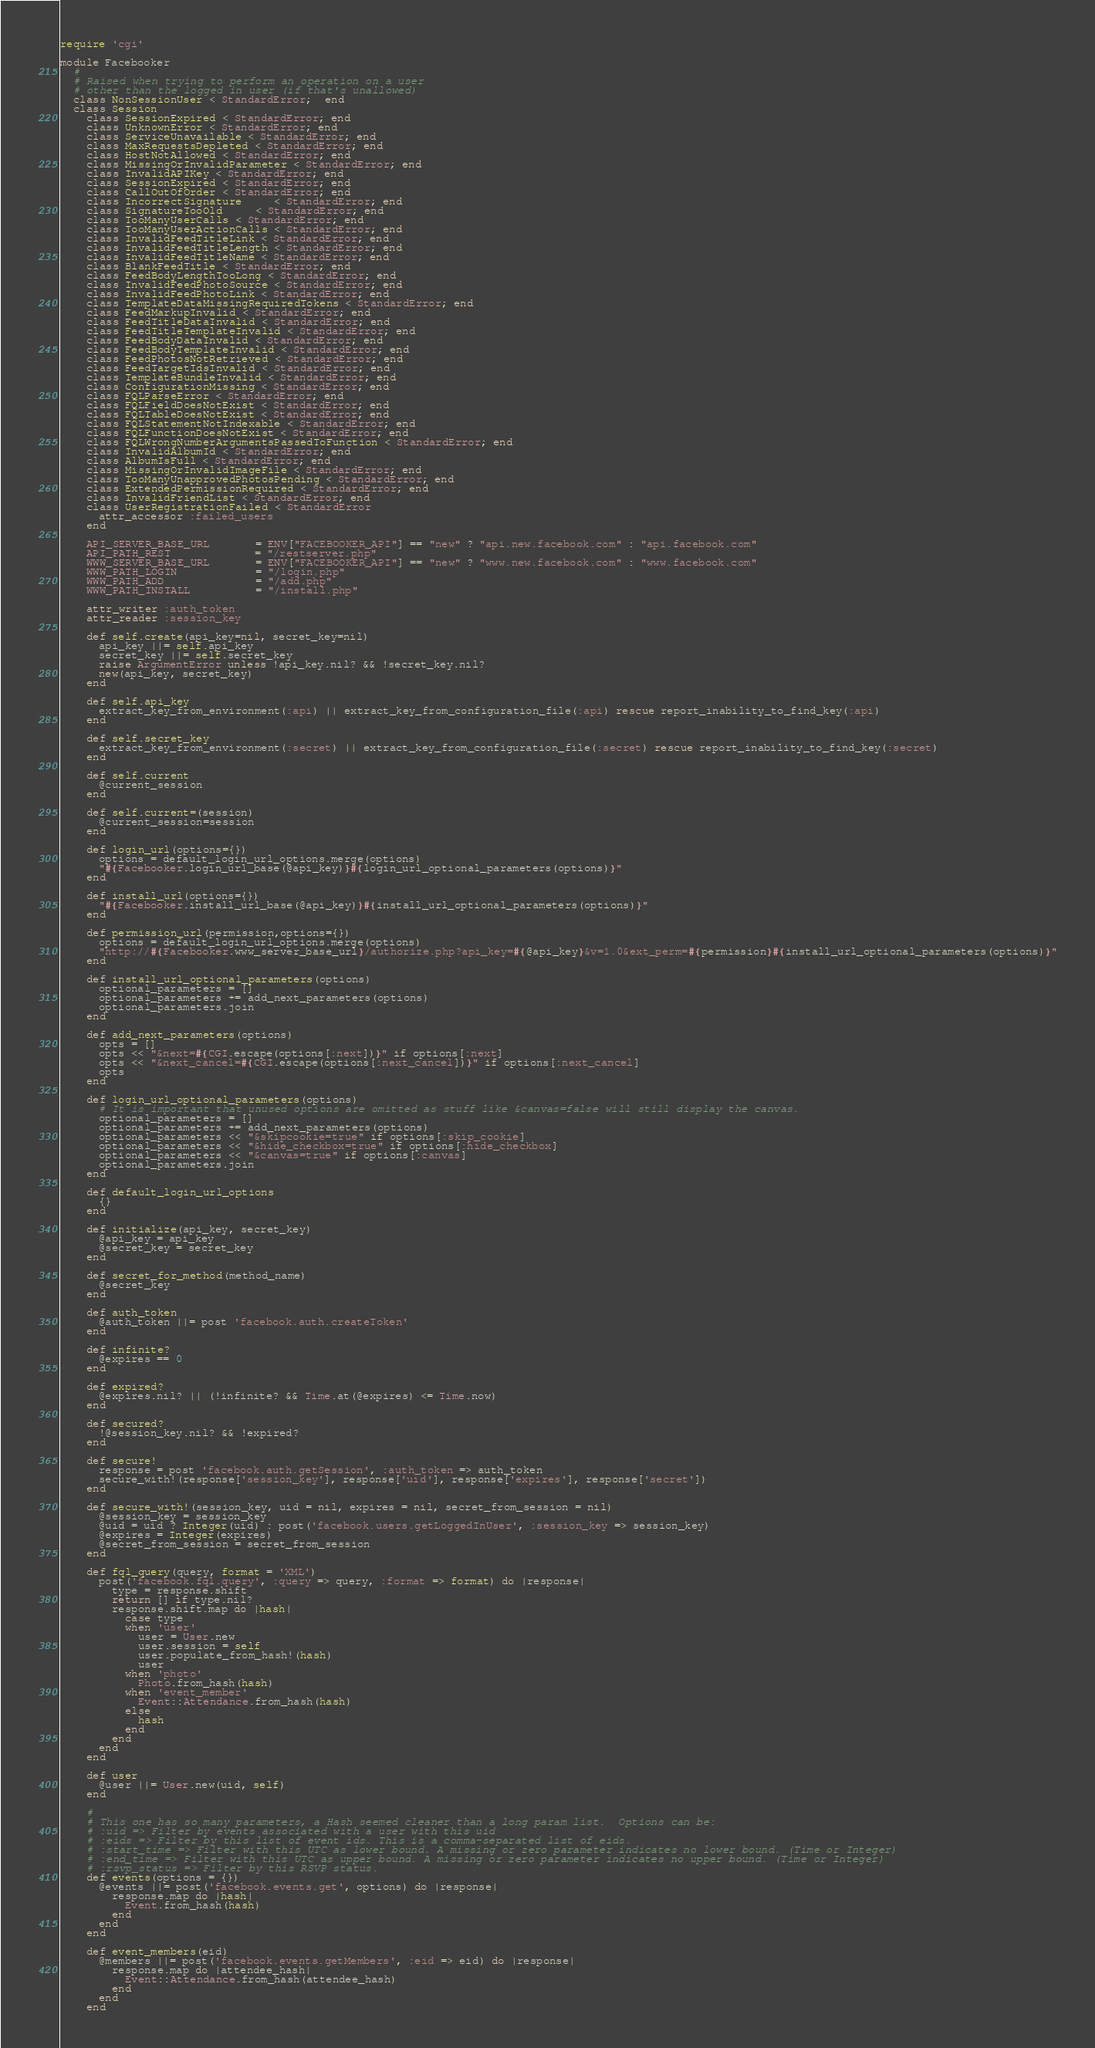Convert code to text. <code><loc_0><loc_0><loc_500><loc_500><_Ruby_>require 'cgi'

module Facebooker
  #
  # Raised when trying to perform an operation on a user
  # other than the logged in user (if that's unallowed)
  class NonSessionUser < StandardError;  end
  class Session
    class SessionExpired < StandardError; end
    class UnknownError < StandardError; end
    class ServiceUnavailable < StandardError; end
    class MaxRequestsDepleted < StandardError; end
    class HostNotAllowed < StandardError; end
    class MissingOrInvalidParameter < StandardError; end
    class InvalidAPIKey < StandardError; end
    class SessionExpired < StandardError; end
    class CallOutOfOrder < StandardError; end
    class IncorrectSignature     < StandardError; end
    class SignatureTooOld     < StandardError; end
    class TooManyUserCalls < StandardError; end
    class TooManyUserActionCalls < StandardError; end
    class InvalidFeedTitleLink < StandardError; end
    class InvalidFeedTitleLength < StandardError; end
    class InvalidFeedTitleName < StandardError; end
    class BlankFeedTitle < StandardError; end
    class FeedBodyLengthTooLong < StandardError; end
    class InvalidFeedPhotoSource < StandardError; end
    class InvalidFeedPhotoLink < StandardError; end    
    class TemplateDataMissingRequiredTokens < StandardError; end
    class FeedMarkupInvalid < StandardError; end
    class FeedTitleDataInvalid < StandardError; end
    class FeedTitleTemplateInvalid < StandardError; end
    class FeedBodyDataInvalid < StandardError; end
    class FeedBodyTemplateInvalid < StandardError; end
    class FeedPhotosNotRetrieved < StandardError; end
    class FeedTargetIdsInvalid < StandardError; end
    class TemplateBundleInvalid < StandardError; end
    class ConfigurationMissing < StandardError; end
    class FQLParseError < StandardError; end
    class FQLFieldDoesNotExist < StandardError; end
    class FQLTableDoesNotExist < StandardError; end
    class FQLStatementNotIndexable < StandardError; end
    class FQLFunctionDoesNotExist < StandardError; end
    class FQLWrongNumberArgumentsPassedToFunction < StandardError; end
    class InvalidAlbumId < StandardError; end
    class AlbumIsFull < StandardError; end
    class MissingOrInvalidImageFile < StandardError; end
    class TooManyUnapprovedPhotosPending < StandardError; end
    class ExtendedPermissionRequired < StandardError; end
    class InvalidFriendList < StandardError; end
    class UserRegistrationFailed < StandardError
      attr_accessor :failed_users
    end
    
    API_SERVER_BASE_URL       = ENV["FACEBOOKER_API"] == "new" ? "api.new.facebook.com" : "api.facebook.com"
    API_PATH_REST             = "/restserver.php"
    WWW_SERVER_BASE_URL       = ENV["FACEBOOKER_API"] == "new" ? "www.new.facebook.com" : "www.facebook.com"
    WWW_PATH_LOGIN            = "/login.php"
    WWW_PATH_ADD              = "/add.php"
    WWW_PATH_INSTALL          = "/install.php"
    
    attr_writer :auth_token
    attr_reader :session_key
    
    def self.create(api_key=nil, secret_key=nil)
      api_key ||= self.api_key
      secret_key ||= self.secret_key
      raise ArgumentError unless !api_key.nil? && !secret_key.nil?
      new(api_key, secret_key)
    end
    
    def self.api_key
      extract_key_from_environment(:api) || extract_key_from_configuration_file(:api) rescue report_inability_to_find_key(:api)
    end
    
    def self.secret_key
      extract_key_from_environment(:secret) || extract_key_from_configuration_file(:secret) rescue report_inability_to_find_key(:secret)
    end
    
    def self.current
      @current_session
    end
    
    def self.current=(session)
      @current_session=session
    end
    
    def login_url(options={})
      options = default_login_url_options.merge(options)
      "#{Facebooker.login_url_base(@api_key)}#{login_url_optional_parameters(options)}"
    end
    
    def install_url(options={})
      "#{Facebooker.install_url_base(@api_key)}#{install_url_optional_parameters(options)}"
    end
    
    def permission_url(permission,options={})
      options = default_login_url_options.merge(options)
      "http://#{Facebooker.www_server_base_url}/authorize.php?api_key=#{@api_key}&v=1.0&ext_perm=#{permission}#{install_url_optional_parameters(options)}"
    end
    
    def install_url_optional_parameters(options)
      optional_parameters = []      
      optional_parameters += add_next_parameters(options)
      optional_parameters.join
    end
    
    def add_next_parameters(options)
      opts = []
      opts << "&next=#{CGI.escape(options[:next])}" if options[:next]
      opts << "&next_cancel=#{CGI.escape(options[:next_cancel])}" if options[:next_cancel]
      opts
    end
    
    def login_url_optional_parameters(options)
      # It is important that unused options are omitted as stuff like &canvas=false will still display the canvas. 
      optional_parameters = []
      optional_parameters += add_next_parameters(options)
      optional_parameters << "&skipcookie=true" if options[:skip_cookie]
      optional_parameters << "&hide_checkbox=true" if options[:hide_checkbox]
      optional_parameters << "&canvas=true" if options[:canvas]
      optional_parameters.join
    end
    
    def default_login_url_options
      {}
    end
    
    def initialize(api_key, secret_key)
      @api_key = api_key
      @secret_key = secret_key
    end
    
    def secret_for_method(method_name)
      @secret_key
    end
      
    def auth_token
      @auth_token ||= post 'facebook.auth.createToken'
    end
    
    def infinite?
      @expires == 0
    end
    
    def expired?
      @expires.nil? || (!infinite? && Time.at(@expires) <= Time.now)
    end
    
    def secured?
      !@session_key.nil? && !expired?
    end
    
    def secure!
      response = post 'facebook.auth.getSession', :auth_token => auth_token
      secure_with!(response['session_key'], response['uid'], response['expires'], response['secret'])
    end    
    
    def secure_with!(session_key, uid = nil, expires = nil, secret_from_session = nil)
      @session_key = session_key
      @uid = uid ? Integer(uid) : post('facebook.users.getLoggedInUser', :session_key => session_key)
      @expires = Integer(expires)
      @secret_from_session = secret_from_session
    end
    
    def fql_query(query, format = 'XML')
      post('facebook.fql.query', :query => query, :format => format) do |response|
        type = response.shift
        return [] if type.nil?
        response.shift.map do |hash|
          case type
          when 'user'
            user = User.new
            user.session = self
            user.populate_from_hash!(hash)
            user
          when 'photo'
            Photo.from_hash(hash)
          when 'event_member'
            Event::Attendance.from_hash(hash)
          else
            hash
          end
        end
      end
    end
    
    def user
      @user ||= User.new(uid, self)
    end
    
    #
    # This one has so many parameters, a Hash seemed cleaner than a long param list.  Options can be:
    # :uid => Filter by events associated with a user with this uid
    # :eids => Filter by this list of event ids. This is a comma-separated list of eids.
    # :start_time => Filter with this UTC as lower bound. A missing or zero parameter indicates no lower bound. (Time or Integer)
    # :end_time => Filter with this UTC as upper bound. A missing or zero parameter indicates no upper bound. (Time or Integer)
    # :rsvp_status => Filter by this RSVP status.
    def events(options = {})
      @events ||= post('facebook.events.get', options) do |response|
        response.map do |hash|
          Event.from_hash(hash)
        end
      end
    end
    
    def event_members(eid)
      @members ||= post('facebook.events.getMembers', :eid => eid) do |response|
        response.map do |attendee_hash|
          Event::Attendance.from_hash(attendee_hash)
        end
      end
    end
</code> 